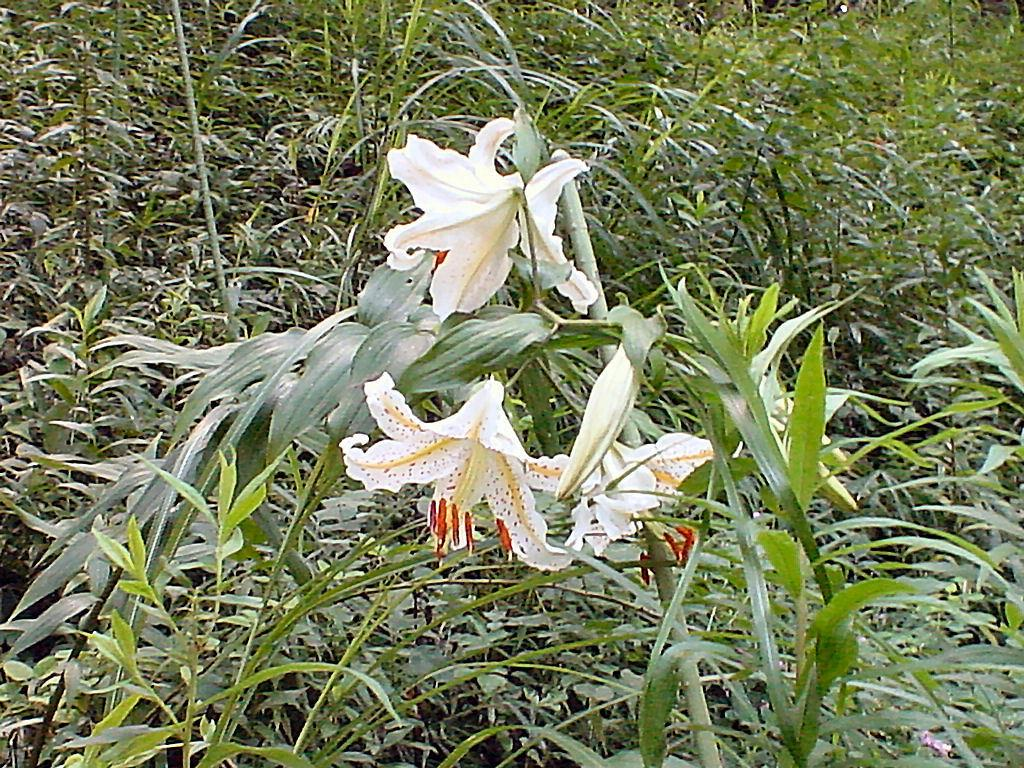What type of living organisms can be seen in the image? Plants and flowers are visible in the image. What is the color of the plants in the image? The plants are green in color. What colors are the flowers in the image? The flowers are white, cream, and red in color. Can you describe the plants in the background of the image? There are plants in the background of the image, but their colors are not specified. What type of calendar is hanging on the wall in the image? There is no calendar present in the image; it features plants and flowers. How many trucks can be seen driving through the garden in the image? There are no trucks visible in the image; it only contains plants and flowers. 